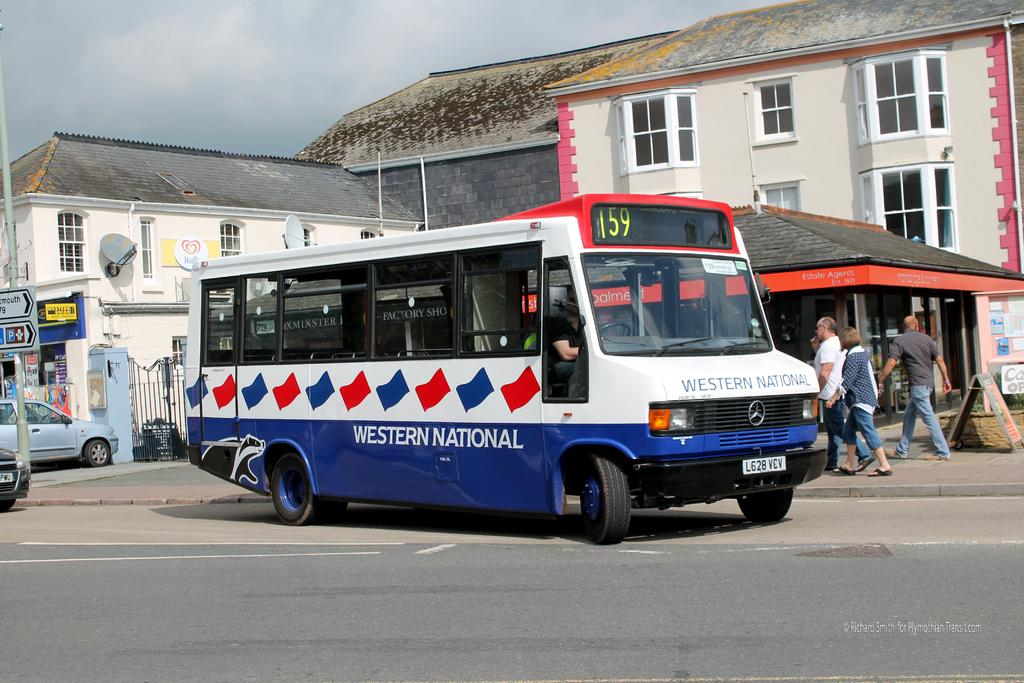Provide a one-sentence caption for the provided image. Western National bus number 159 is driving along the street. 